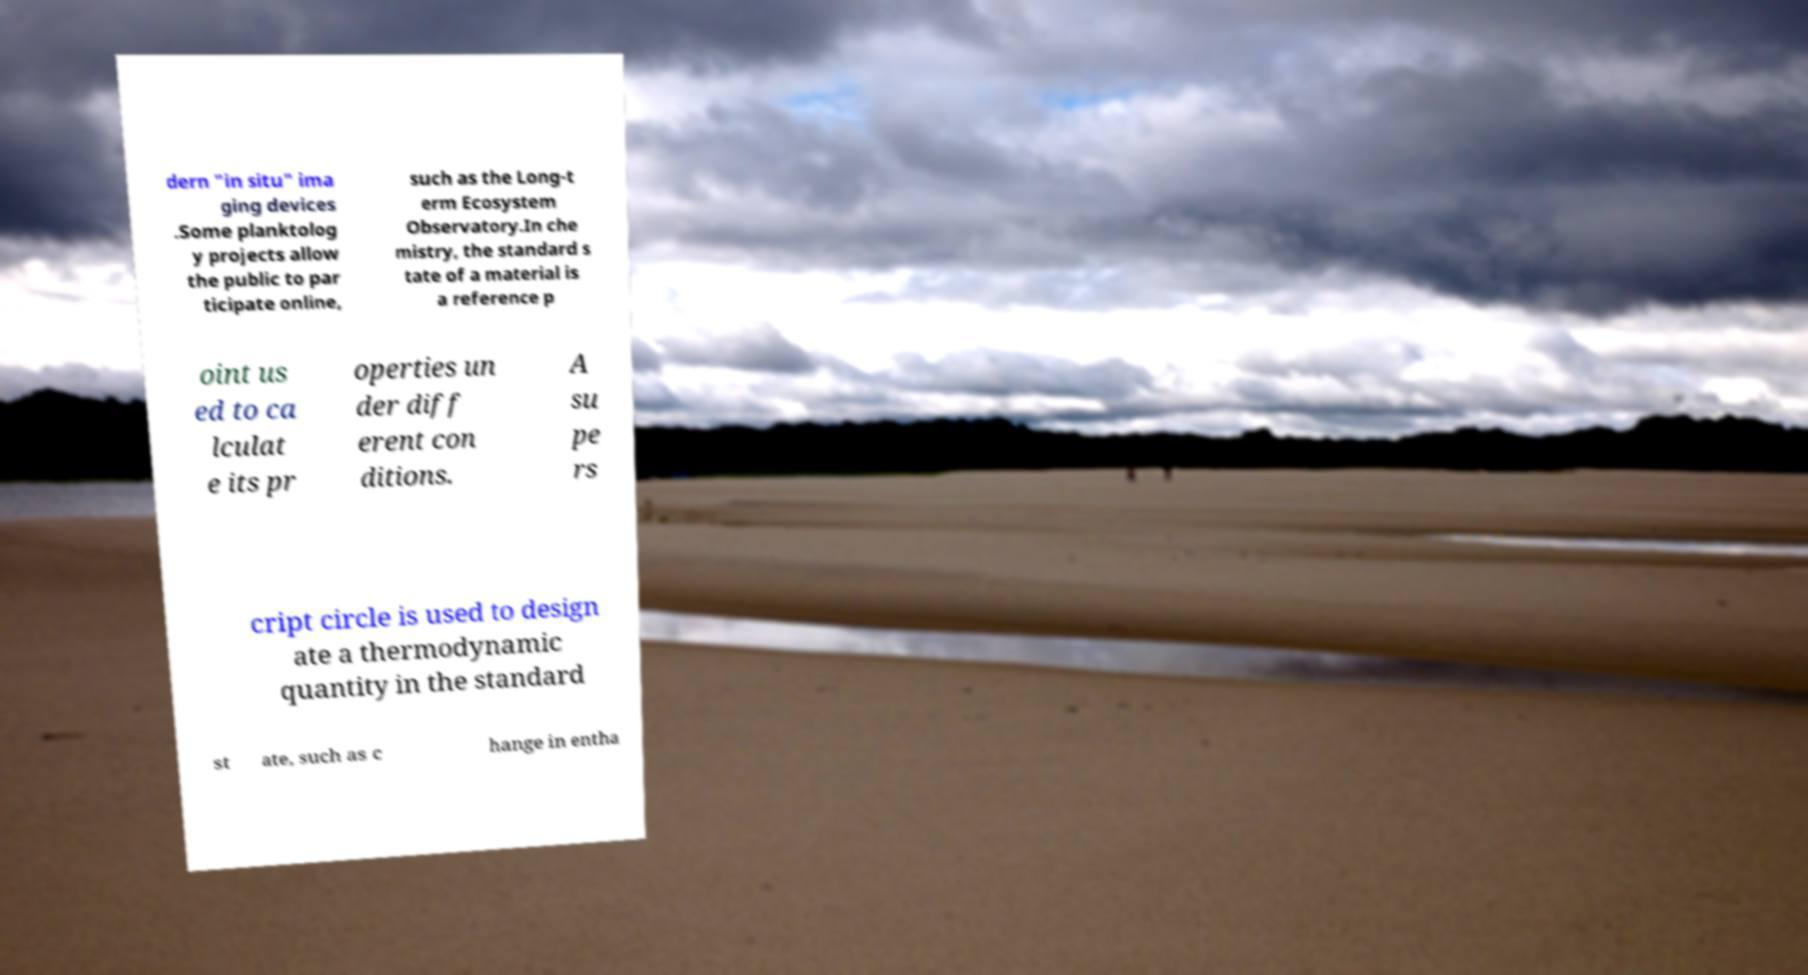What messages or text are displayed in this image? I need them in a readable, typed format. dern "in situ" ima ging devices .Some planktolog y projects allow the public to par ticipate online, such as the Long-t erm Ecosystem Observatory.In che mistry, the standard s tate of a material is a reference p oint us ed to ca lculat e its pr operties un der diff erent con ditions. A su pe rs cript circle is used to design ate a thermodynamic quantity in the standard st ate, such as c hange in entha 